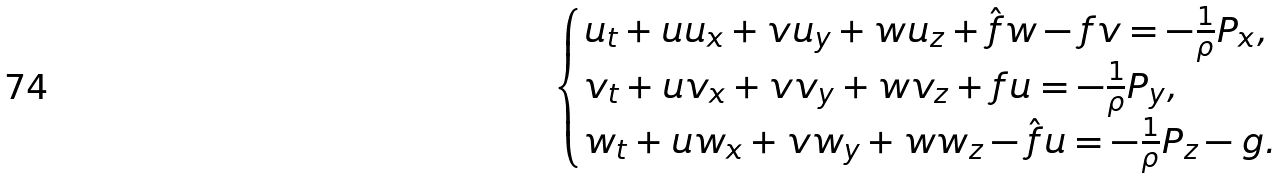<formula> <loc_0><loc_0><loc_500><loc_500>\begin{cases} u _ { t } + u u _ { x } + v u _ { y } + w u _ { z } + \hat { f } w - f v = - \frac { 1 } { \rho } P _ { x } , \\ v _ { t } + u v _ { x } + v v _ { y } + w v _ { z } + f u = - \frac { 1 } { \rho } P _ { y } , \\ w _ { t } + u w _ { x } + v w _ { y } + w w _ { z } - \hat { f } u = - \frac { 1 } { \rho } P _ { z } - g . \end{cases}</formula> 